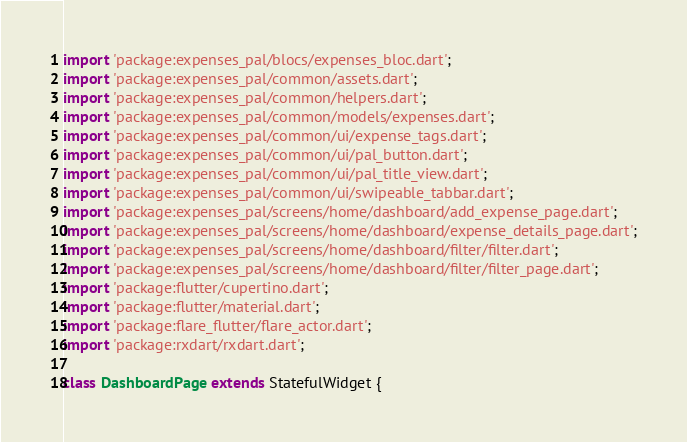Convert code to text. <code><loc_0><loc_0><loc_500><loc_500><_Dart_>import 'package:expenses_pal/blocs/expenses_bloc.dart';
import 'package:expenses_pal/common/assets.dart';
import 'package:expenses_pal/common/helpers.dart';
import 'package:expenses_pal/common/models/expenses.dart';
import 'package:expenses_pal/common/ui/expense_tags.dart';
import 'package:expenses_pal/common/ui/pal_button.dart';
import 'package:expenses_pal/common/ui/pal_title_view.dart';
import 'package:expenses_pal/common/ui/swipeable_tabbar.dart';
import 'package:expenses_pal/screens/home/dashboard/add_expense_page.dart';
import 'package:expenses_pal/screens/home/dashboard/expense_details_page.dart';
import 'package:expenses_pal/screens/home/dashboard/filter/filter.dart';
import 'package:expenses_pal/screens/home/dashboard/filter/filter_page.dart';
import 'package:flutter/cupertino.dart';
import 'package:flutter/material.dart';
import 'package:flare_flutter/flare_actor.dart';
import 'package:rxdart/rxdart.dart';

class DashboardPage extends StatefulWidget {</code> 